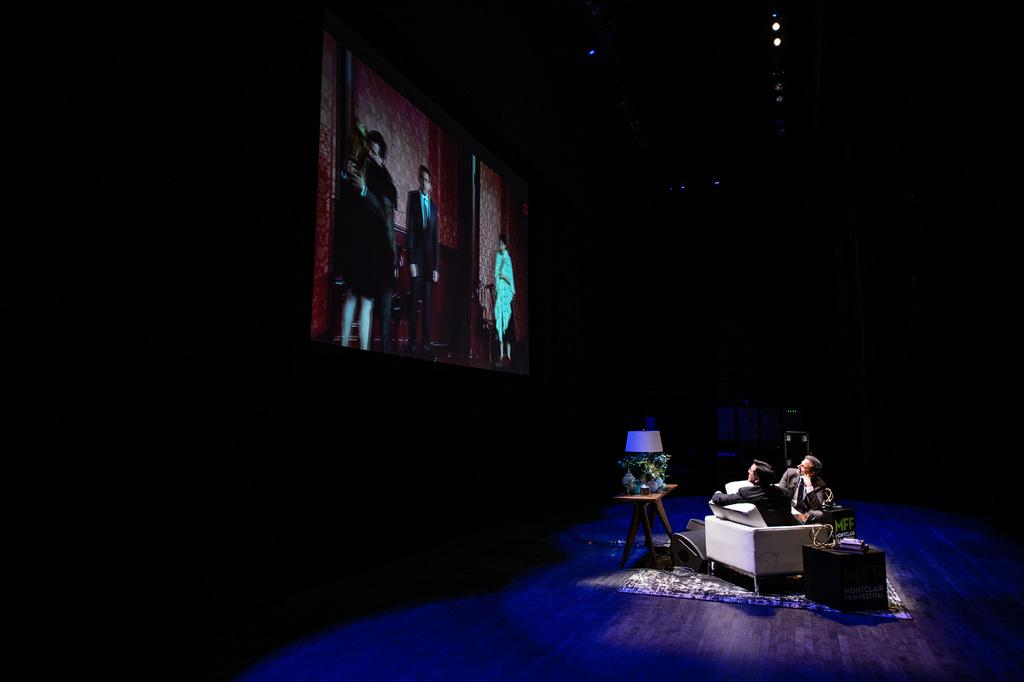How many people are in the image? There are two persons in the image. What are the persons doing in the image? The persons are sitting on the floor. Where are the persons located in the image? The persons are on a stage. What is on the wall behind the persons? There is a screen on the wall behind the persons. What furniture is present in the image? There is a table with a lamp on it in the image. How is the table positioned in the image? The table is on the floor. What type of beef is being served on the table in the image? There is no beef present in the image; the table has a lamp on it. Can you tell me how many ladybugs are crawling on the persons in the image? There are no ladybugs present in the image; the persons are sitting on the floor. 